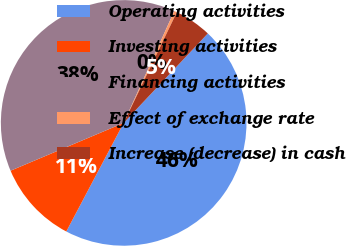<chart> <loc_0><loc_0><loc_500><loc_500><pie_chart><fcel>Operating activities<fcel>Investing activities<fcel>Financing activities<fcel>Effect of exchange rate<fcel>Increase (decrease) in cash<nl><fcel>45.73%<fcel>10.9%<fcel>38.13%<fcel>0.36%<fcel>4.89%<nl></chart> 